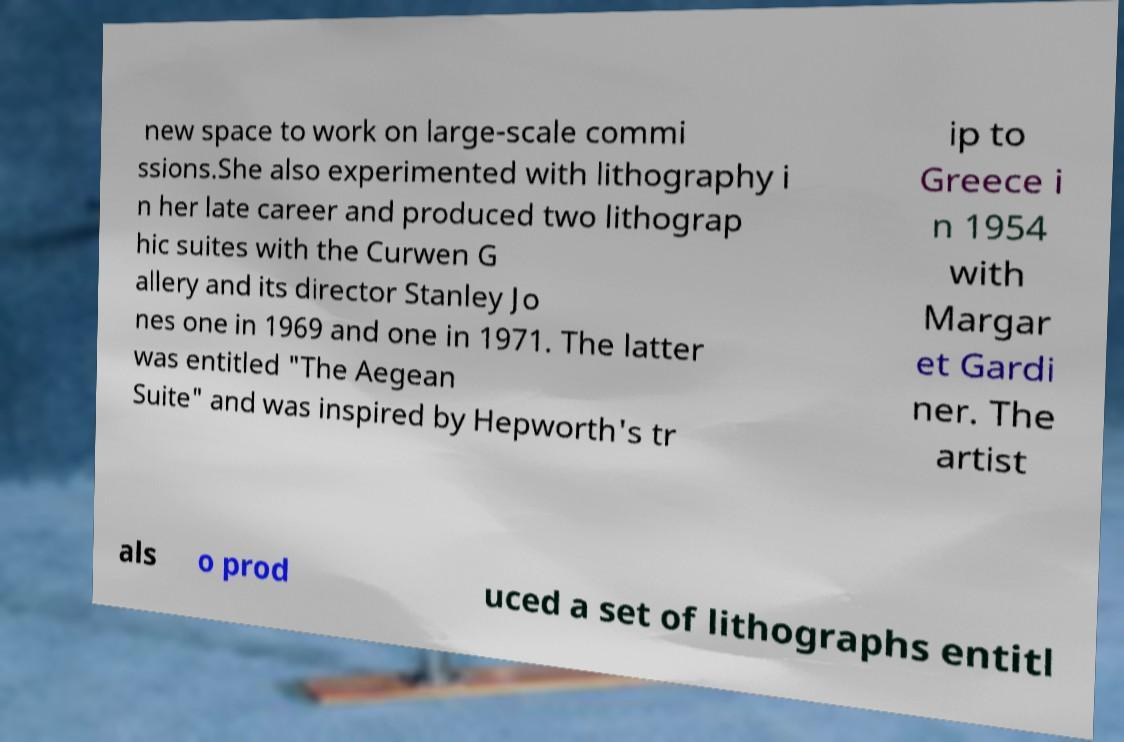Please read and relay the text visible in this image. What does it say? new space to work on large-scale commi ssions.She also experimented with lithography i n her late career and produced two lithograp hic suites with the Curwen G allery and its director Stanley Jo nes one in 1969 and one in 1971. The latter was entitled "The Aegean Suite" and was inspired by Hepworth's tr ip to Greece i n 1954 with Margar et Gardi ner. The artist als o prod uced a set of lithographs entitl 